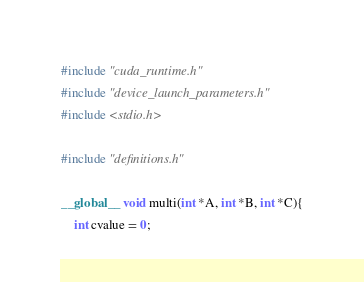<code> <loc_0><loc_0><loc_500><loc_500><_Cuda_>#include "cuda_runtime.h"
#include "device_launch_parameters.h"
#include <stdio.h>
 
#include "definitions.h"

__global__ void multi(int *A, int *B, int *C){
	int cvalue = 0;</code> 